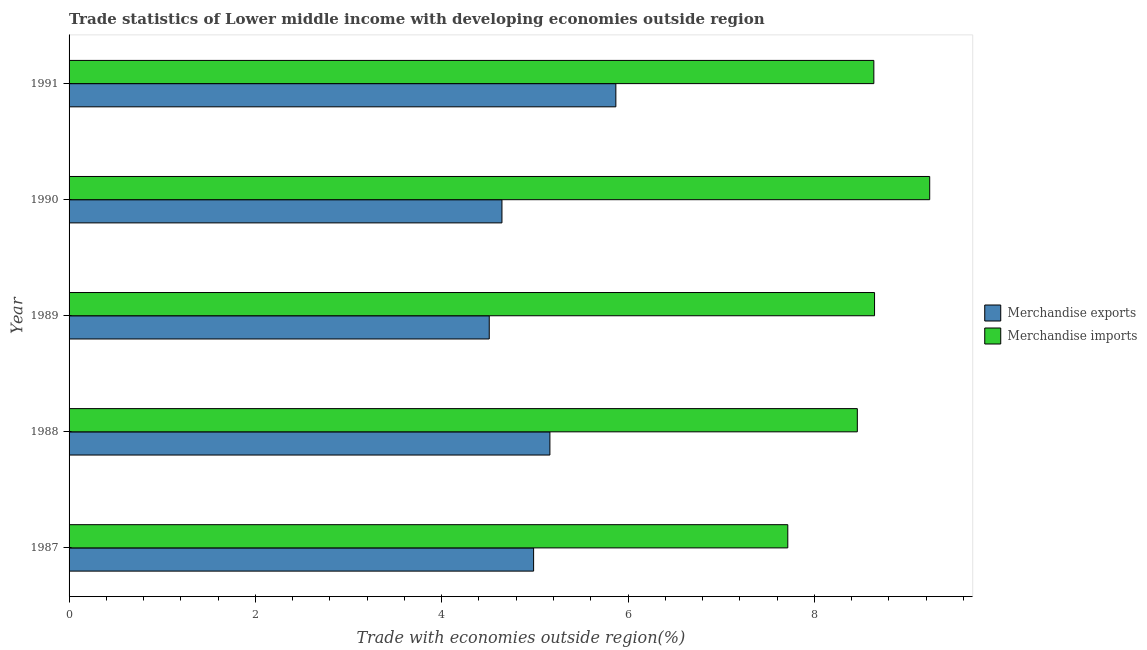How many different coloured bars are there?
Offer a very short reply. 2. What is the label of the 1st group of bars from the top?
Make the answer very short. 1991. In how many cases, is the number of bars for a given year not equal to the number of legend labels?
Your answer should be compact. 0. What is the merchandise exports in 1987?
Your answer should be compact. 4.99. Across all years, what is the maximum merchandise imports?
Your answer should be compact. 9.24. Across all years, what is the minimum merchandise imports?
Your answer should be very brief. 7.71. In which year was the merchandise imports maximum?
Offer a very short reply. 1990. In which year was the merchandise imports minimum?
Provide a succinct answer. 1987. What is the total merchandise imports in the graph?
Keep it short and to the point. 42.7. What is the difference between the merchandise imports in 1988 and that in 1990?
Your response must be concise. -0.78. What is the difference between the merchandise imports in 1988 and the merchandise exports in 1991?
Provide a short and direct response. 2.59. What is the average merchandise exports per year?
Keep it short and to the point. 5.04. In the year 1987, what is the difference between the merchandise imports and merchandise exports?
Give a very brief answer. 2.73. In how many years, is the merchandise imports greater than 6 %?
Your response must be concise. 5. What is the ratio of the merchandise imports in 1988 to that in 1991?
Your response must be concise. 0.98. Is the merchandise imports in 1989 less than that in 1990?
Your answer should be compact. Yes. Is the difference between the merchandise imports in 1988 and 1991 greater than the difference between the merchandise exports in 1988 and 1991?
Keep it short and to the point. Yes. What is the difference between the highest and the second highest merchandise imports?
Your answer should be very brief. 0.59. What is the difference between the highest and the lowest merchandise imports?
Ensure brevity in your answer.  1.52. What does the 1st bar from the top in 1991 represents?
Your answer should be very brief. Merchandise imports. How many bars are there?
Make the answer very short. 10. Are all the bars in the graph horizontal?
Your answer should be very brief. Yes. How many years are there in the graph?
Keep it short and to the point. 5. What is the difference between two consecutive major ticks on the X-axis?
Provide a short and direct response. 2. Does the graph contain grids?
Ensure brevity in your answer.  No. How many legend labels are there?
Give a very brief answer. 2. How are the legend labels stacked?
Ensure brevity in your answer.  Vertical. What is the title of the graph?
Offer a very short reply. Trade statistics of Lower middle income with developing economies outside region. Does "Start a business" appear as one of the legend labels in the graph?
Your response must be concise. No. What is the label or title of the X-axis?
Give a very brief answer. Trade with economies outside region(%). What is the label or title of the Y-axis?
Your answer should be compact. Year. What is the Trade with economies outside region(%) of Merchandise exports in 1987?
Provide a succinct answer. 4.99. What is the Trade with economies outside region(%) in Merchandise imports in 1987?
Give a very brief answer. 7.71. What is the Trade with economies outside region(%) in Merchandise exports in 1988?
Your answer should be very brief. 5.16. What is the Trade with economies outside region(%) of Merchandise imports in 1988?
Your answer should be compact. 8.46. What is the Trade with economies outside region(%) in Merchandise exports in 1989?
Offer a very short reply. 4.51. What is the Trade with economies outside region(%) of Merchandise imports in 1989?
Offer a very short reply. 8.65. What is the Trade with economies outside region(%) in Merchandise exports in 1990?
Offer a very short reply. 4.65. What is the Trade with economies outside region(%) in Merchandise imports in 1990?
Offer a terse response. 9.24. What is the Trade with economies outside region(%) of Merchandise exports in 1991?
Your response must be concise. 5.87. What is the Trade with economies outside region(%) in Merchandise imports in 1991?
Give a very brief answer. 8.64. Across all years, what is the maximum Trade with economies outside region(%) in Merchandise exports?
Give a very brief answer. 5.87. Across all years, what is the maximum Trade with economies outside region(%) of Merchandise imports?
Provide a short and direct response. 9.24. Across all years, what is the minimum Trade with economies outside region(%) of Merchandise exports?
Make the answer very short. 4.51. Across all years, what is the minimum Trade with economies outside region(%) in Merchandise imports?
Offer a very short reply. 7.71. What is the total Trade with economies outside region(%) in Merchandise exports in the graph?
Your answer should be compact. 25.17. What is the total Trade with economies outside region(%) in Merchandise imports in the graph?
Provide a succinct answer. 42.7. What is the difference between the Trade with economies outside region(%) of Merchandise exports in 1987 and that in 1988?
Ensure brevity in your answer.  -0.17. What is the difference between the Trade with economies outside region(%) of Merchandise imports in 1987 and that in 1988?
Ensure brevity in your answer.  -0.75. What is the difference between the Trade with economies outside region(%) in Merchandise exports in 1987 and that in 1989?
Make the answer very short. 0.48. What is the difference between the Trade with economies outside region(%) of Merchandise imports in 1987 and that in 1989?
Ensure brevity in your answer.  -0.93. What is the difference between the Trade with economies outside region(%) of Merchandise exports in 1987 and that in 1990?
Offer a terse response. 0.34. What is the difference between the Trade with economies outside region(%) in Merchandise imports in 1987 and that in 1990?
Make the answer very short. -1.52. What is the difference between the Trade with economies outside region(%) of Merchandise exports in 1987 and that in 1991?
Your answer should be compact. -0.88. What is the difference between the Trade with economies outside region(%) of Merchandise imports in 1987 and that in 1991?
Ensure brevity in your answer.  -0.92. What is the difference between the Trade with economies outside region(%) in Merchandise exports in 1988 and that in 1989?
Your answer should be compact. 0.65. What is the difference between the Trade with economies outside region(%) in Merchandise imports in 1988 and that in 1989?
Provide a succinct answer. -0.18. What is the difference between the Trade with economies outside region(%) of Merchandise exports in 1988 and that in 1990?
Your answer should be very brief. 0.51. What is the difference between the Trade with economies outside region(%) of Merchandise imports in 1988 and that in 1990?
Your response must be concise. -0.78. What is the difference between the Trade with economies outside region(%) in Merchandise exports in 1988 and that in 1991?
Make the answer very short. -0.71. What is the difference between the Trade with economies outside region(%) in Merchandise imports in 1988 and that in 1991?
Give a very brief answer. -0.18. What is the difference between the Trade with economies outside region(%) of Merchandise exports in 1989 and that in 1990?
Make the answer very short. -0.14. What is the difference between the Trade with economies outside region(%) in Merchandise imports in 1989 and that in 1990?
Provide a short and direct response. -0.59. What is the difference between the Trade with economies outside region(%) of Merchandise exports in 1989 and that in 1991?
Provide a succinct answer. -1.36. What is the difference between the Trade with economies outside region(%) in Merchandise imports in 1989 and that in 1991?
Keep it short and to the point. 0.01. What is the difference between the Trade with economies outside region(%) of Merchandise exports in 1990 and that in 1991?
Your answer should be compact. -1.22. What is the difference between the Trade with economies outside region(%) in Merchandise imports in 1990 and that in 1991?
Your response must be concise. 0.6. What is the difference between the Trade with economies outside region(%) of Merchandise exports in 1987 and the Trade with economies outside region(%) of Merchandise imports in 1988?
Provide a succinct answer. -3.47. What is the difference between the Trade with economies outside region(%) of Merchandise exports in 1987 and the Trade with economies outside region(%) of Merchandise imports in 1989?
Give a very brief answer. -3.66. What is the difference between the Trade with economies outside region(%) in Merchandise exports in 1987 and the Trade with economies outside region(%) in Merchandise imports in 1990?
Offer a terse response. -4.25. What is the difference between the Trade with economies outside region(%) of Merchandise exports in 1987 and the Trade with economies outside region(%) of Merchandise imports in 1991?
Your answer should be very brief. -3.65. What is the difference between the Trade with economies outside region(%) in Merchandise exports in 1988 and the Trade with economies outside region(%) in Merchandise imports in 1989?
Your response must be concise. -3.48. What is the difference between the Trade with economies outside region(%) of Merchandise exports in 1988 and the Trade with economies outside region(%) of Merchandise imports in 1990?
Keep it short and to the point. -4.08. What is the difference between the Trade with economies outside region(%) of Merchandise exports in 1988 and the Trade with economies outside region(%) of Merchandise imports in 1991?
Your answer should be very brief. -3.48. What is the difference between the Trade with economies outside region(%) in Merchandise exports in 1989 and the Trade with economies outside region(%) in Merchandise imports in 1990?
Offer a terse response. -4.73. What is the difference between the Trade with economies outside region(%) of Merchandise exports in 1989 and the Trade with economies outside region(%) of Merchandise imports in 1991?
Make the answer very short. -4.13. What is the difference between the Trade with economies outside region(%) in Merchandise exports in 1990 and the Trade with economies outside region(%) in Merchandise imports in 1991?
Offer a very short reply. -3.99. What is the average Trade with economies outside region(%) of Merchandise exports per year?
Keep it short and to the point. 5.03. What is the average Trade with economies outside region(%) in Merchandise imports per year?
Provide a succinct answer. 8.54. In the year 1987, what is the difference between the Trade with economies outside region(%) of Merchandise exports and Trade with economies outside region(%) of Merchandise imports?
Your answer should be very brief. -2.73. In the year 1988, what is the difference between the Trade with economies outside region(%) of Merchandise exports and Trade with economies outside region(%) of Merchandise imports?
Give a very brief answer. -3.3. In the year 1989, what is the difference between the Trade with economies outside region(%) in Merchandise exports and Trade with economies outside region(%) in Merchandise imports?
Keep it short and to the point. -4.14. In the year 1990, what is the difference between the Trade with economies outside region(%) of Merchandise exports and Trade with economies outside region(%) of Merchandise imports?
Give a very brief answer. -4.59. In the year 1991, what is the difference between the Trade with economies outside region(%) in Merchandise exports and Trade with economies outside region(%) in Merchandise imports?
Your answer should be very brief. -2.77. What is the ratio of the Trade with economies outside region(%) of Merchandise exports in 1987 to that in 1988?
Provide a succinct answer. 0.97. What is the ratio of the Trade with economies outside region(%) in Merchandise imports in 1987 to that in 1988?
Your answer should be very brief. 0.91. What is the ratio of the Trade with economies outside region(%) in Merchandise exports in 1987 to that in 1989?
Your answer should be very brief. 1.11. What is the ratio of the Trade with economies outside region(%) in Merchandise imports in 1987 to that in 1989?
Provide a succinct answer. 0.89. What is the ratio of the Trade with economies outside region(%) in Merchandise exports in 1987 to that in 1990?
Your response must be concise. 1.07. What is the ratio of the Trade with economies outside region(%) in Merchandise imports in 1987 to that in 1990?
Your response must be concise. 0.84. What is the ratio of the Trade with economies outside region(%) in Merchandise exports in 1987 to that in 1991?
Offer a very short reply. 0.85. What is the ratio of the Trade with economies outside region(%) of Merchandise imports in 1987 to that in 1991?
Your answer should be very brief. 0.89. What is the ratio of the Trade with economies outside region(%) in Merchandise exports in 1988 to that in 1989?
Offer a very short reply. 1.14. What is the ratio of the Trade with economies outside region(%) of Merchandise imports in 1988 to that in 1989?
Your answer should be compact. 0.98. What is the ratio of the Trade with economies outside region(%) in Merchandise exports in 1988 to that in 1990?
Ensure brevity in your answer.  1.11. What is the ratio of the Trade with economies outside region(%) of Merchandise imports in 1988 to that in 1990?
Your answer should be compact. 0.92. What is the ratio of the Trade with economies outside region(%) in Merchandise exports in 1988 to that in 1991?
Your response must be concise. 0.88. What is the ratio of the Trade with economies outside region(%) in Merchandise imports in 1988 to that in 1991?
Keep it short and to the point. 0.98. What is the ratio of the Trade with economies outside region(%) of Merchandise exports in 1989 to that in 1990?
Your response must be concise. 0.97. What is the ratio of the Trade with economies outside region(%) in Merchandise imports in 1989 to that in 1990?
Give a very brief answer. 0.94. What is the ratio of the Trade with economies outside region(%) in Merchandise exports in 1989 to that in 1991?
Keep it short and to the point. 0.77. What is the ratio of the Trade with economies outside region(%) in Merchandise exports in 1990 to that in 1991?
Offer a very short reply. 0.79. What is the ratio of the Trade with economies outside region(%) in Merchandise imports in 1990 to that in 1991?
Provide a short and direct response. 1.07. What is the difference between the highest and the second highest Trade with economies outside region(%) in Merchandise exports?
Provide a succinct answer. 0.71. What is the difference between the highest and the second highest Trade with economies outside region(%) of Merchandise imports?
Make the answer very short. 0.59. What is the difference between the highest and the lowest Trade with economies outside region(%) in Merchandise exports?
Offer a terse response. 1.36. What is the difference between the highest and the lowest Trade with economies outside region(%) in Merchandise imports?
Provide a short and direct response. 1.52. 